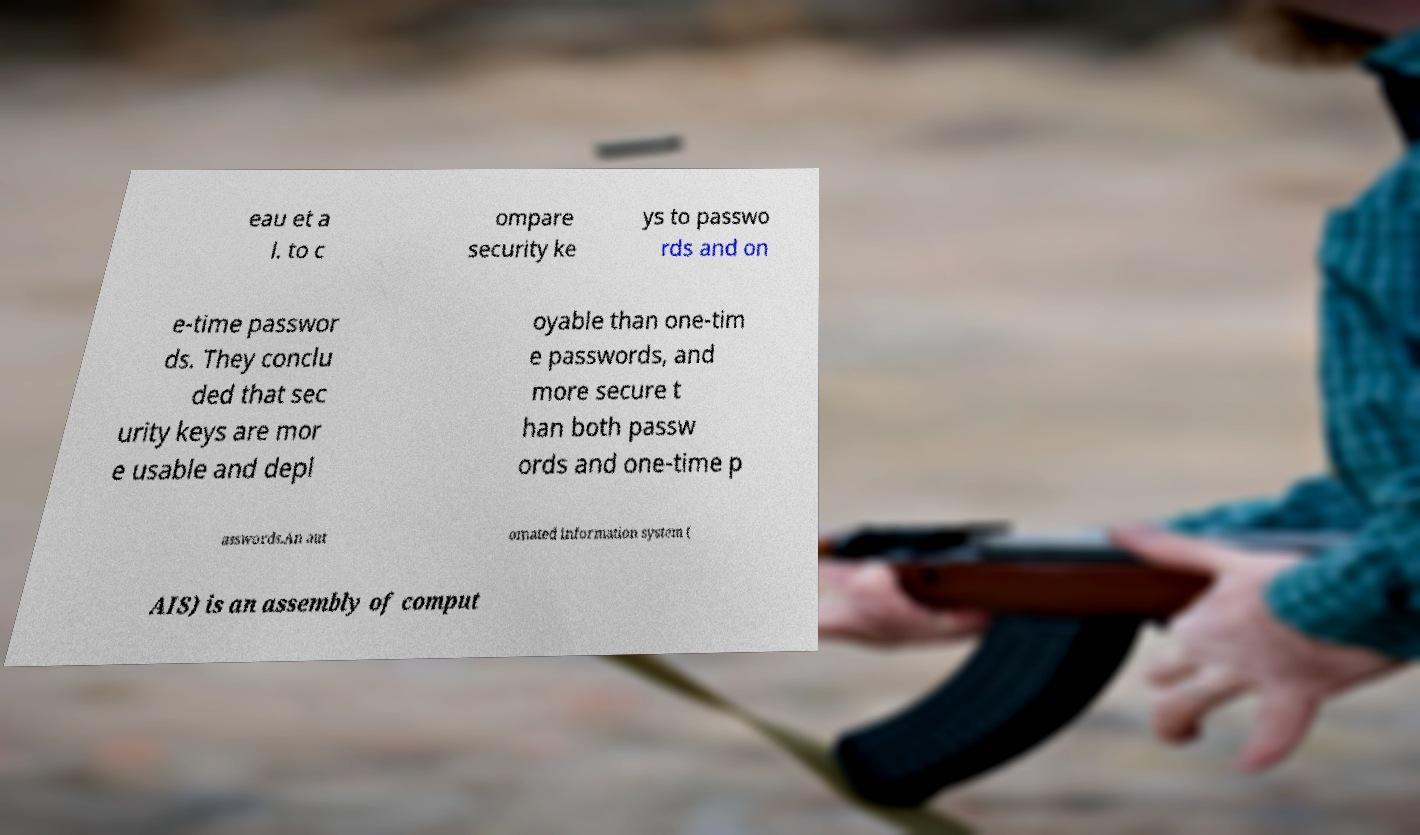Could you assist in decoding the text presented in this image and type it out clearly? eau et a l. to c ompare security ke ys to passwo rds and on e-time passwor ds. They conclu ded that sec urity keys are mor e usable and depl oyable than one-tim e passwords, and more secure t han both passw ords and one-time p asswords.An aut omated information system ( AIS) is an assembly of comput 